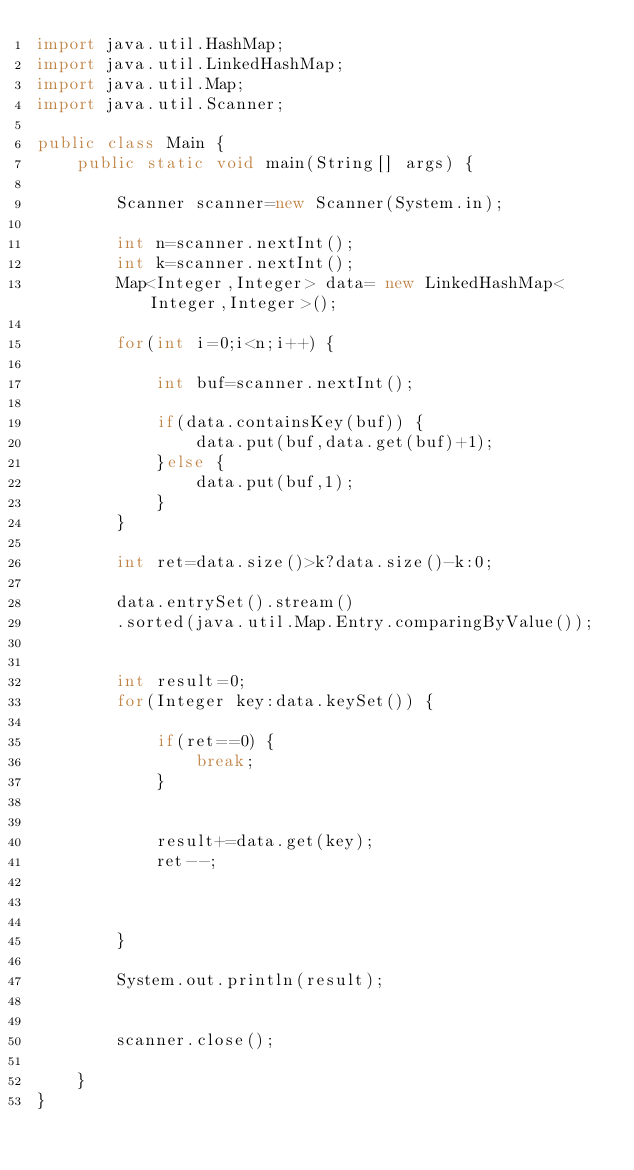<code> <loc_0><loc_0><loc_500><loc_500><_Java_>import java.util.HashMap;
import java.util.LinkedHashMap;
import java.util.Map;
import java.util.Scanner;

public class Main {
	public static void main(String[] args) {

		Scanner scanner=new Scanner(System.in);

		int n=scanner.nextInt();
		int k=scanner.nextInt();
		Map<Integer,Integer> data= new LinkedHashMap<Integer,Integer>();

		for(int i=0;i<n;i++) {

			int buf=scanner.nextInt();

			if(data.containsKey(buf)) {
				data.put(buf,data.get(buf)+1);
			}else {
				data.put(buf,1);
			}
		}

		int ret=data.size()>k?data.size()-k:0;

		data.entrySet().stream()
        .sorted(java.util.Map.Entry.comparingByValue());


		int result=0;
		for(Integer key:data.keySet()) {
			
			if(ret==0) {
				break;
			}


			result+=data.get(key);
			ret--;

			

		}

		System.out.println(result);


		scanner.close();

	}
}</code> 